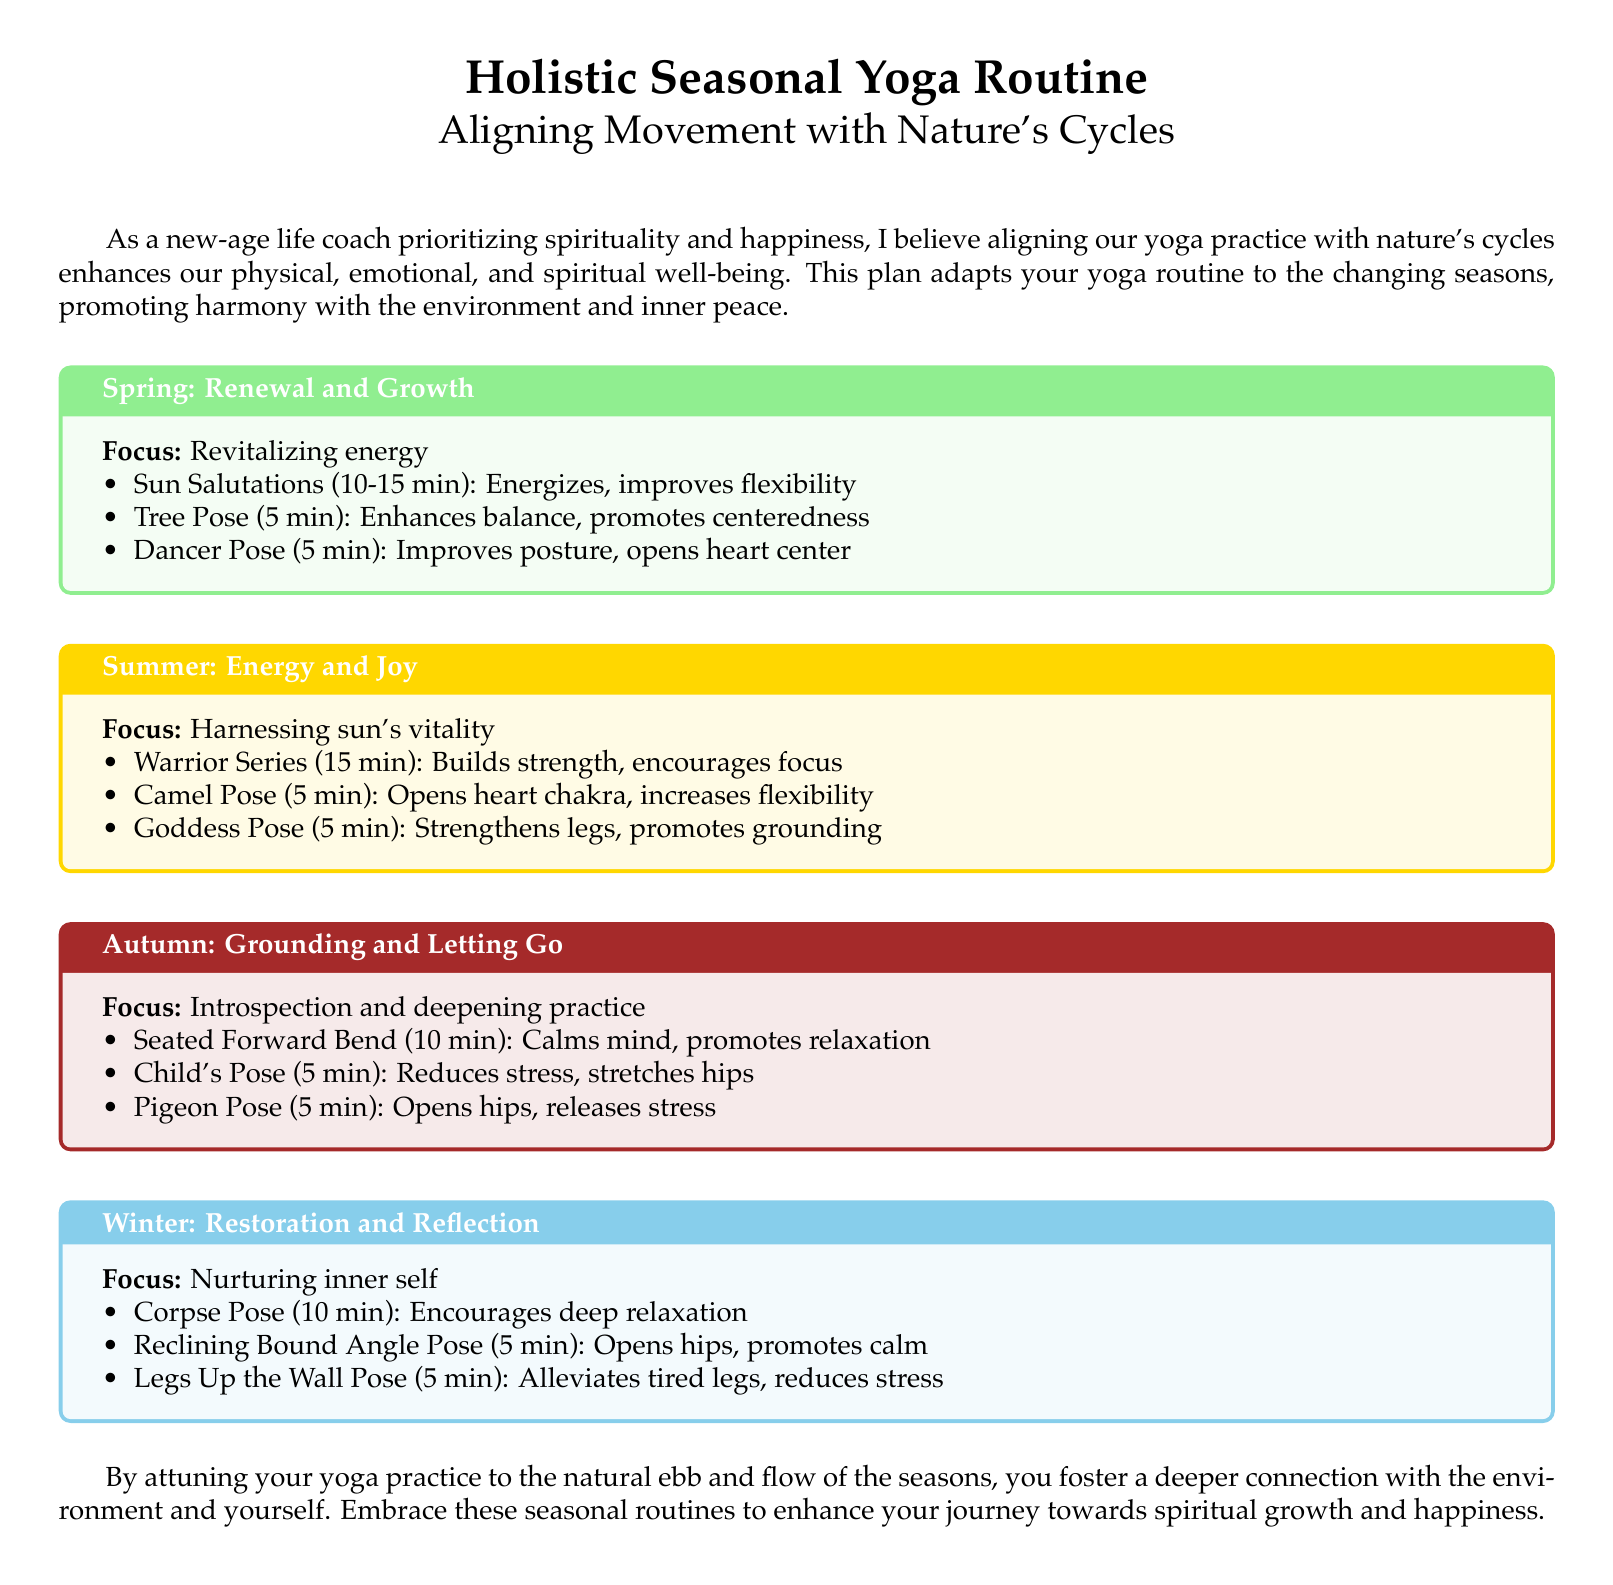What is the main purpose of the document? The document outlines a holistic yoga routine that aligns movement with nature's cycles for enhanced well-being.
Answer: Aligning movement with nature's cycles How long should the Sun Salutations be performed in Spring? The document specifies a duration for Sun Salutations during the Spring season.
Answer: 10-15 min Which pose in Summer opens the heart chakra? The document indicates poses related to specific focuses for each season.
Answer: Camel Pose What is the focus during Autumn? The focus for Autumn is described in the document.
Answer: Introspection and deepening practice What is the duration of Corpse Pose in Winter? The document provides the duration for each recommended pose for the Winter season.
Answer: 10 min How many poses are listed for Summer? The number of poses for the Summer season is mentioned in the document.
Answer: 3 Which pose is recommended for grounding in Summer? The document identifies specific poses related to grounding for each season.
Answer: Goddess Pose What is the color associated with Spring in the document? The document uses colors to represent different seasons.
Answer: springgreen 